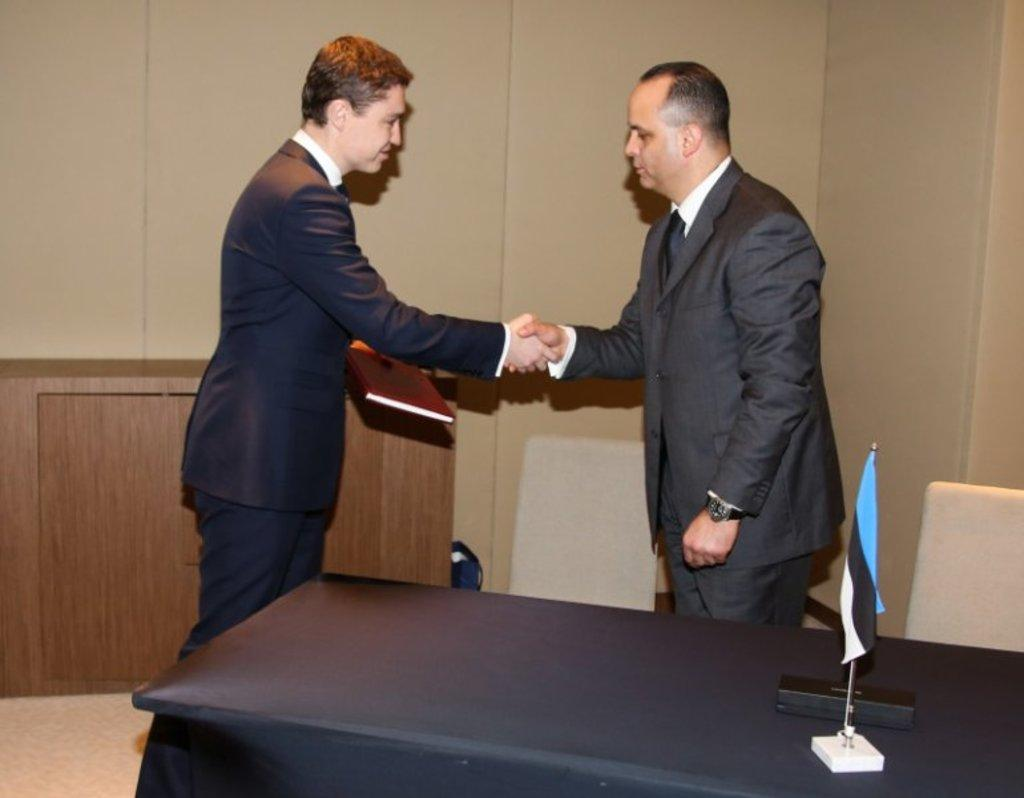How many people are in the image? There are two men in the image. What are the men doing in the image? The men are standing and shaking hands. Can you describe any objects that one of the men is holding? One of the men is holding a book. How many children are playing with the square in the image? There are no children or squares present in the image. What type of pleasure can be seen on the men's faces in the image? The provided facts do not mention the men's facial expressions, so we cannot determine if they are experiencing pleasure or any other emotion. 